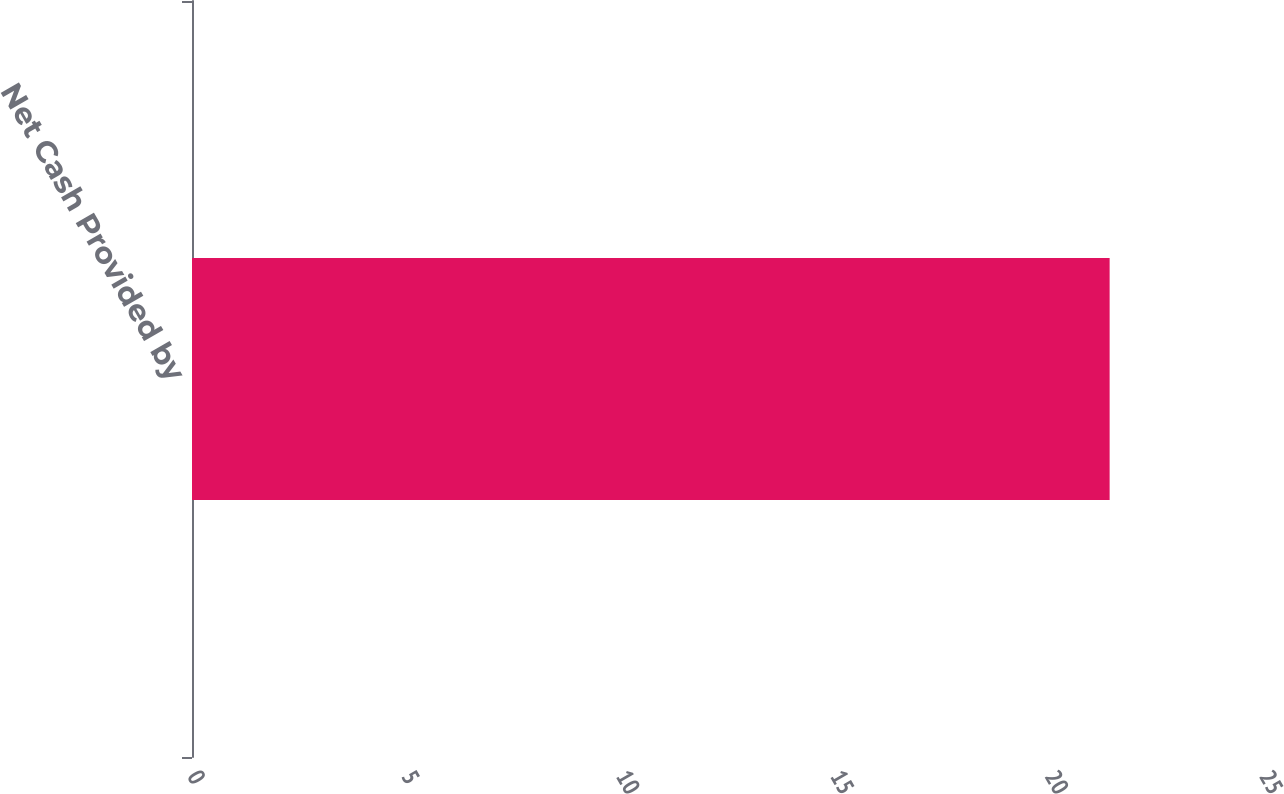Convert chart. <chart><loc_0><loc_0><loc_500><loc_500><bar_chart><fcel>Net Cash Provided by<nl><fcel>21.4<nl></chart> 